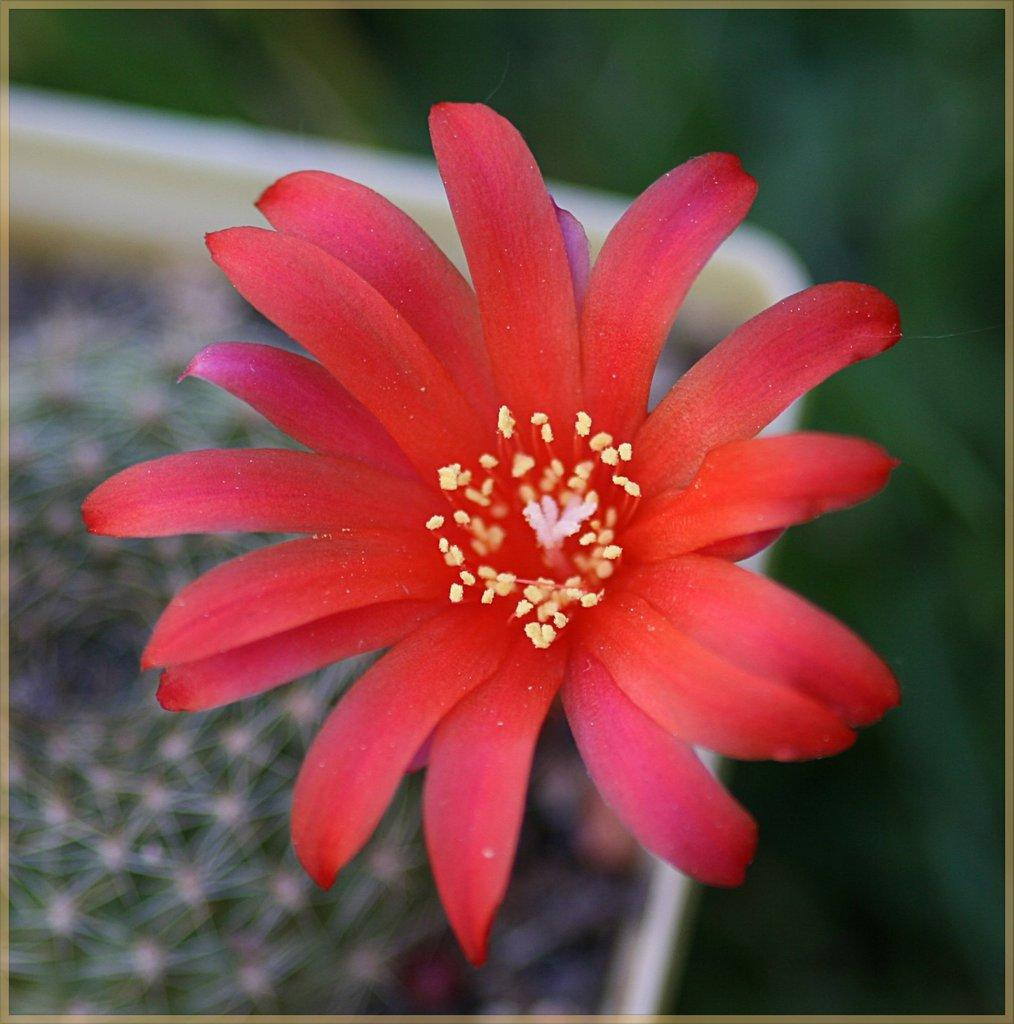What is the main subject of the image? There is a flower in the image. Can you describe the colors of the flower? The flower has red and yellow colors. What can be observed about the background of the image? The background of the image is blurred. How many toys are scattered around the carriage in the image? There are no toys or carriages present in the image; it features a flower with a blurred background. 